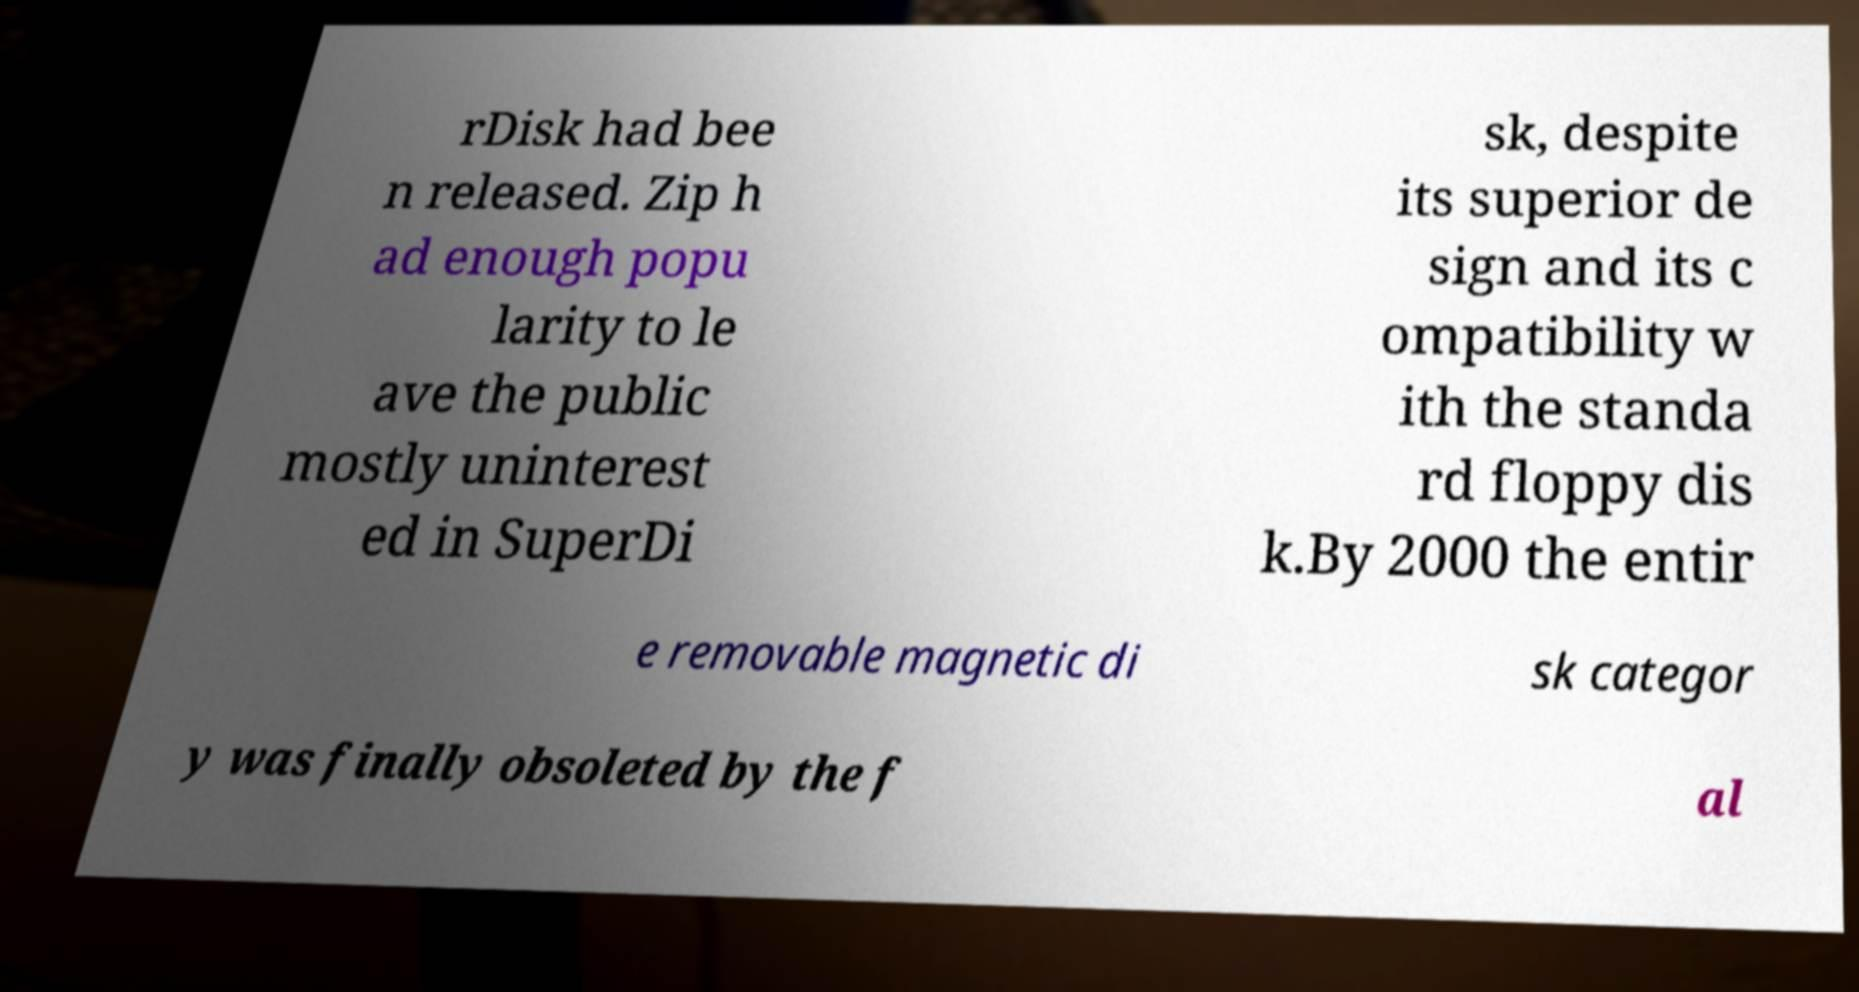Could you extract and type out the text from this image? rDisk had bee n released. Zip h ad enough popu larity to le ave the public mostly uninterest ed in SuperDi sk, despite its superior de sign and its c ompatibility w ith the standa rd floppy dis k.By 2000 the entir e removable magnetic di sk categor y was finally obsoleted by the f al 